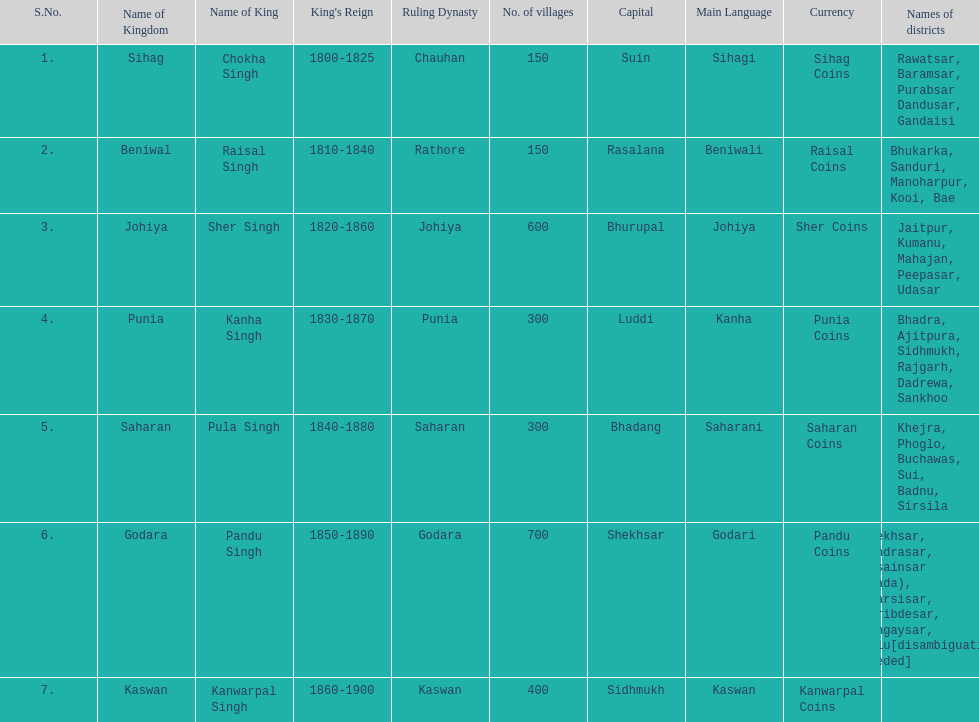Which kingdom contained the second most villages, next only to godara? Johiya. 